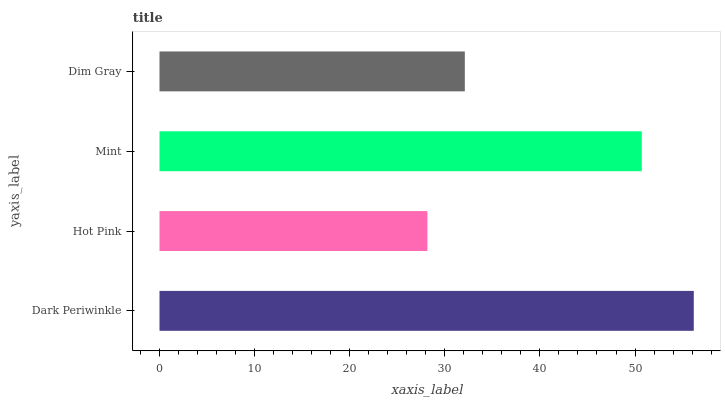Is Hot Pink the minimum?
Answer yes or no. Yes. Is Dark Periwinkle the maximum?
Answer yes or no. Yes. Is Mint the minimum?
Answer yes or no. No. Is Mint the maximum?
Answer yes or no. No. Is Mint greater than Hot Pink?
Answer yes or no. Yes. Is Hot Pink less than Mint?
Answer yes or no. Yes. Is Hot Pink greater than Mint?
Answer yes or no. No. Is Mint less than Hot Pink?
Answer yes or no. No. Is Mint the high median?
Answer yes or no. Yes. Is Dim Gray the low median?
Answer yes or no. Yes. Is Hot Pink the high median?
Answer yes or no. No. Is Dark Periwinkle the low median?
Answer yes or no. No. 